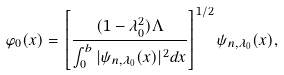<formula> <loc_0><loc_0><loc_500><loc_500>\varphi _ { 0 } ( x ) = \left [ \frac { ( 1 - \lambda _ { 0 } ^ { 2 } ) \Lambda } { \int _ { 0 } ^ { b } | \psi _ { n , \lambda _ { 0 } } ( x ) | ^ { 2 } d x } \right ] ^ { 1 / 2 } \psi _ { n , \lambda _ { 0 } } ( x ) ,</formula> 